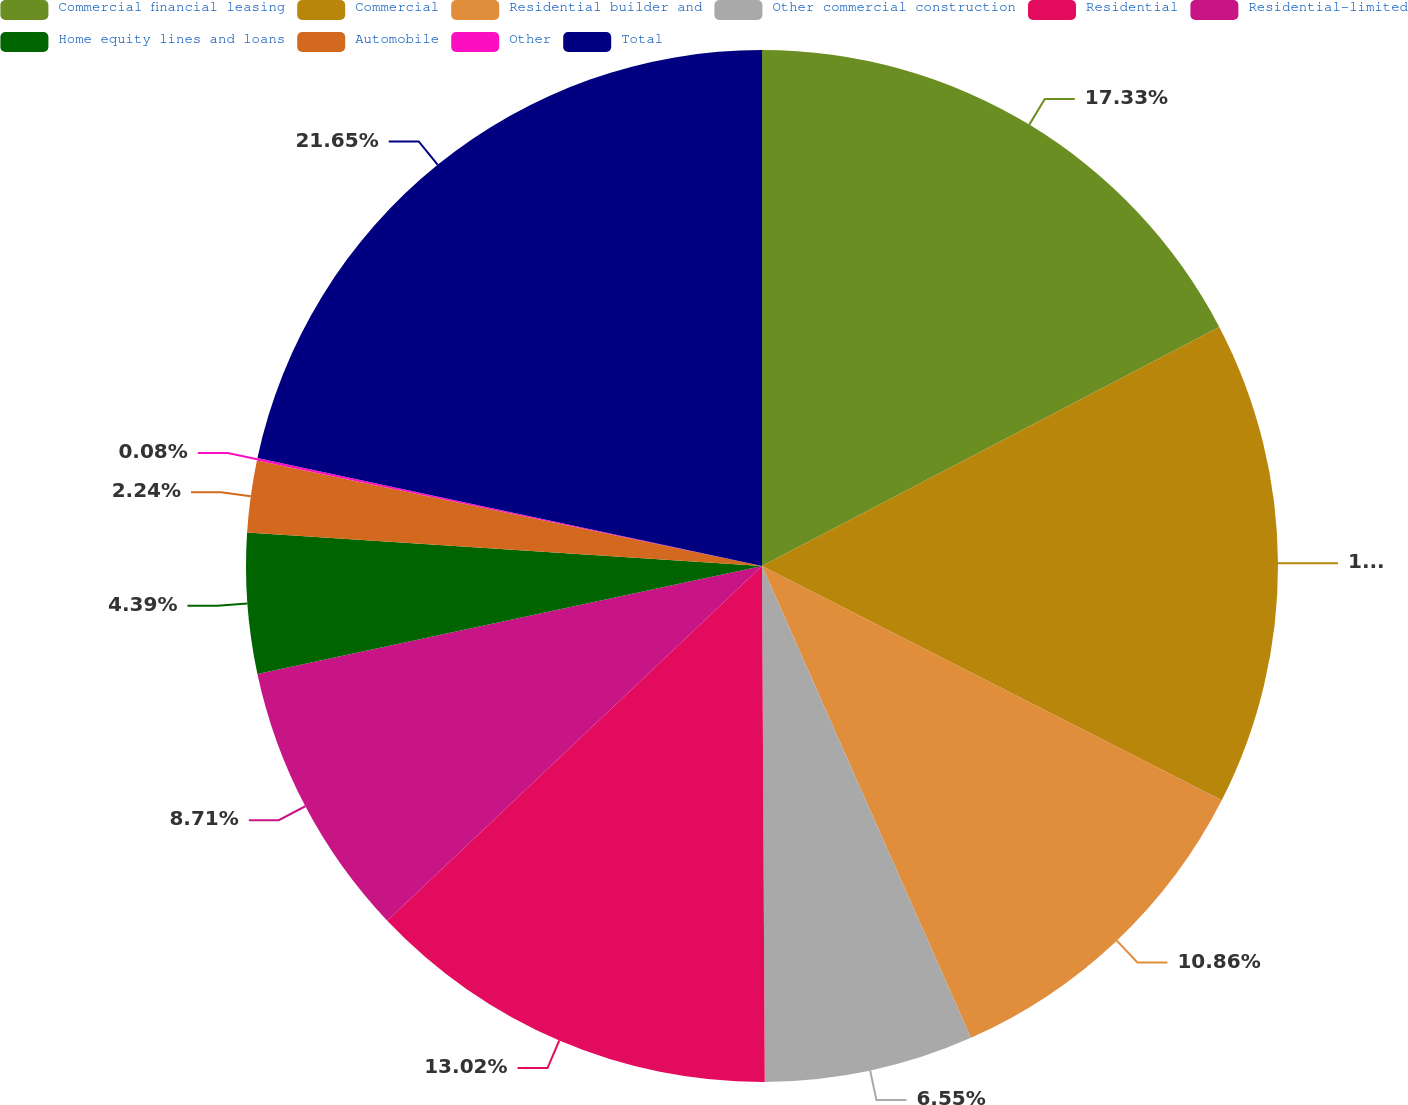Convert chart. <chart><loc_0><loc_0><loc_500><loc_500><pie_chart><fcel>Commercial financial leasing<fcel>Commercial<fcel>Residential builder and<fcel>Other commercial construction<fcel>Residential<fcel>Residential-limited<fcel>Home equity lines and loans<fcel>Automobile<fcel>Other<fcel>Total<nl><fcel>17.33%<fcel>15.17%<fcel>10.86%<fcel>6.55%<fcel>13.02%<fcel>8.71%<fcel>4.39%<fcel>2.24%<fcel>0.08%<fcel>21.64%<nl></chart> 